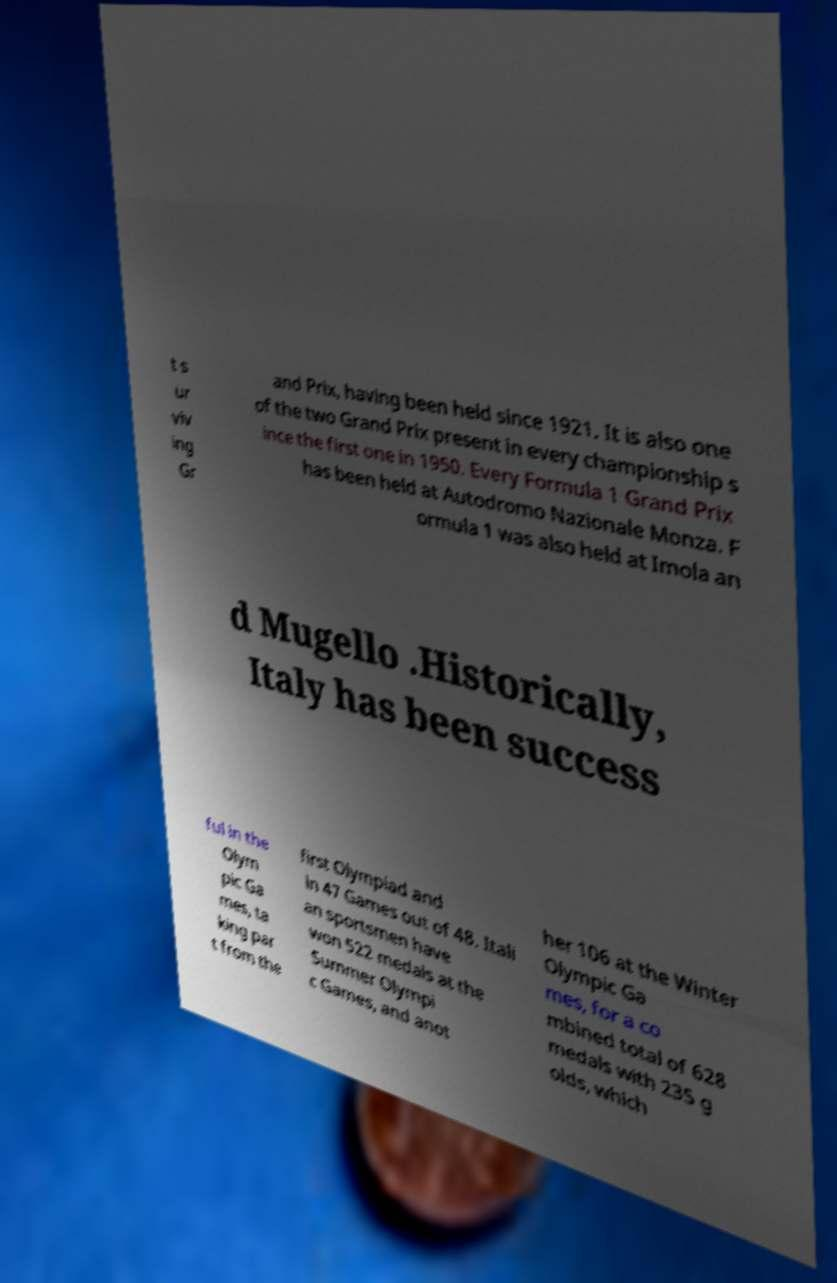There's text embedded in this image that I need extracted. Can you transcribe it verbatim? t s ur viv ing Gr and Prix, having been held since 1921. It is also one of the two Grand Prix present in every championship s ince the first one in 1950. Every Formula 1 Grand Prix has been held at Autodromo Nazionale Monza. F ormula 1 was also held at Imola an d Mugello .Historically, Italy has been success ful in the Olym pic Ga mes, ta king par t from the first Olympiad and in 47 Games out of 48. Itali an sportsmen have won 522 medals at the Summer Olympi c Games, and anot her 106 at the Winter Olympic Ga mes, for a co mbined total of 628 medals with 235 g olds, which 